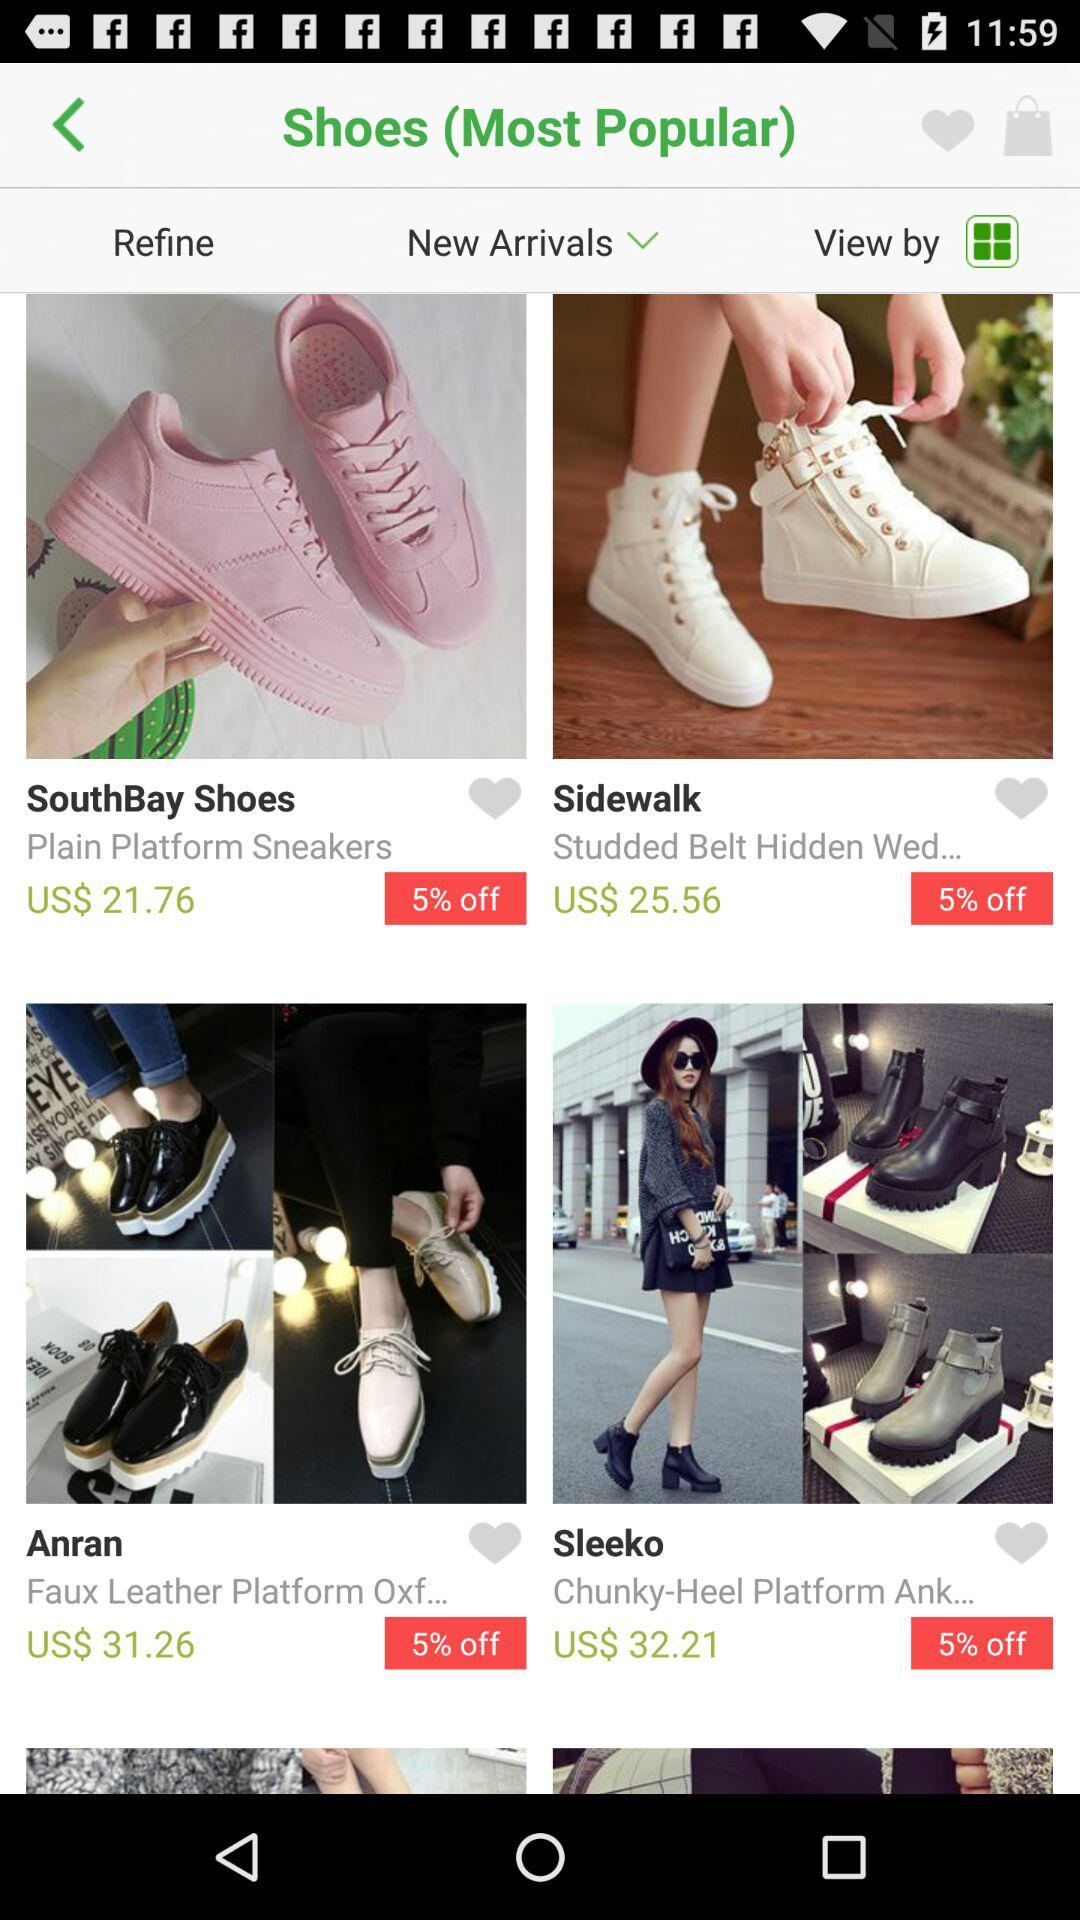What's the Sale Discount percentage on "South Bay Shoes" Brand? The sale discount is 5% off. 